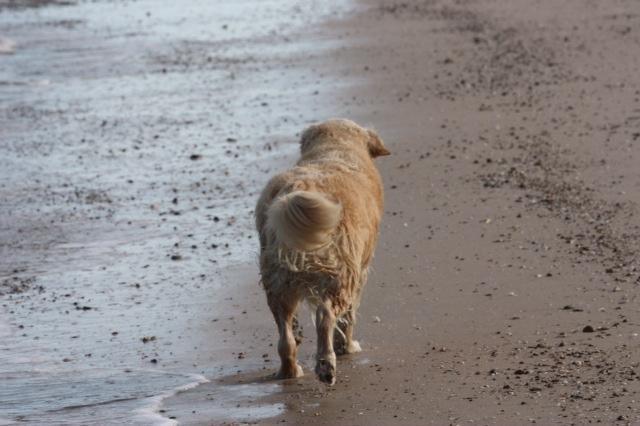How many people are wearing red?
Give a very brief answer. 0. 